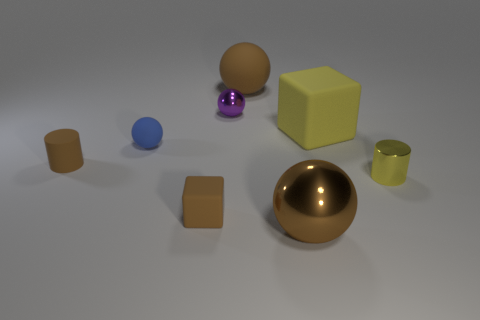What size is the yellow object that is behind the brown rubber cylinder?
Offer a terse response. Large. There is another small thing that is the same shape as the blue rubber thing; what material is it?
Your response must be concise. Metal. There is a big brown object that is in front of the small yellow metal cylinder; what shape is it?
Provide a succinct answer. Sphere. How many small brown rubber things have the same shape as the tiny yellow thing?
Offer a very short reply. 1. Are there the same number of metallic spheres behind the yellow metal object and purple balls that are to the left of the tiny rubber cube?
Keep it short and to the point. No. Is there a sphere made of the same material as the brown block?
Give a very brief answer. Yes. Are the purple thing and the tiny brown cylinder made of the same material?
Keep it short and to the point. No. What number of yellow objects are tiny balls or rubber cubes?
Ensure brevity in your answer.  1. Is the number of metallic objects left of the yellow rubber cube greater than the number of brown cylinders?
Provide a succinct answer. Yes. Are there any tiny things of the same color as the big metallic object?
Ensure brevity in your answer.  Yes. 